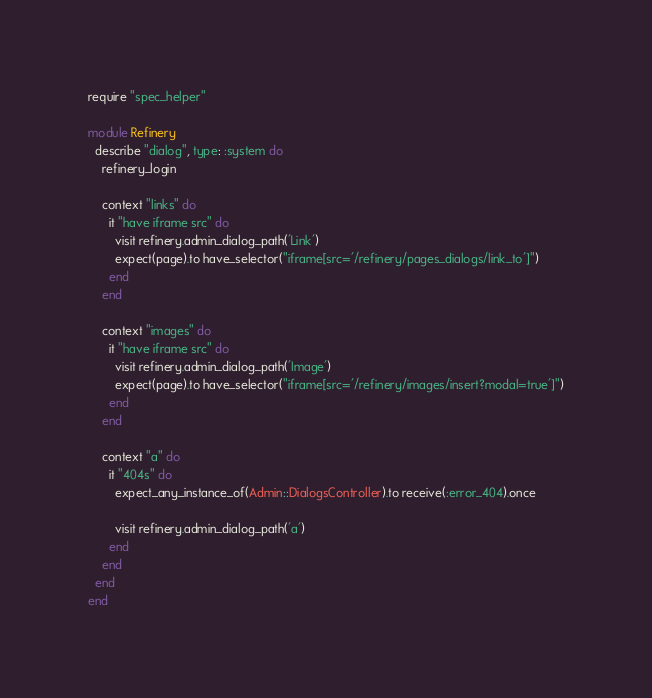<code> <loc_0><loc_0><loc_500><loc_500><_Ruby_>require "spec_helper"

module Refinery
  describe "dialog", type: :system do
    refinery_login

    context "links" do
      it "have iframe src" do
        visit refinery.admin_dialog_path('Link')
        expect(page).to have_selector("iframe[src='/refinery/pages_dialogs/link_to']")
      end
    end

    context "images" do
      it "have iframe src" do
        visit refinery.admin_dialog_path('Image')
        expect(page).to have_selector("iframe[src='/refinery/images/insert?modal=true']")
      end
    end

    context "a" do
      it "404s" do
        expect_any_instance_of(Admin::DialogsController).to receive(:error_404).once

        visit refinery.admin_dialog_path('a')
      end
    end
  end
end
</code> 